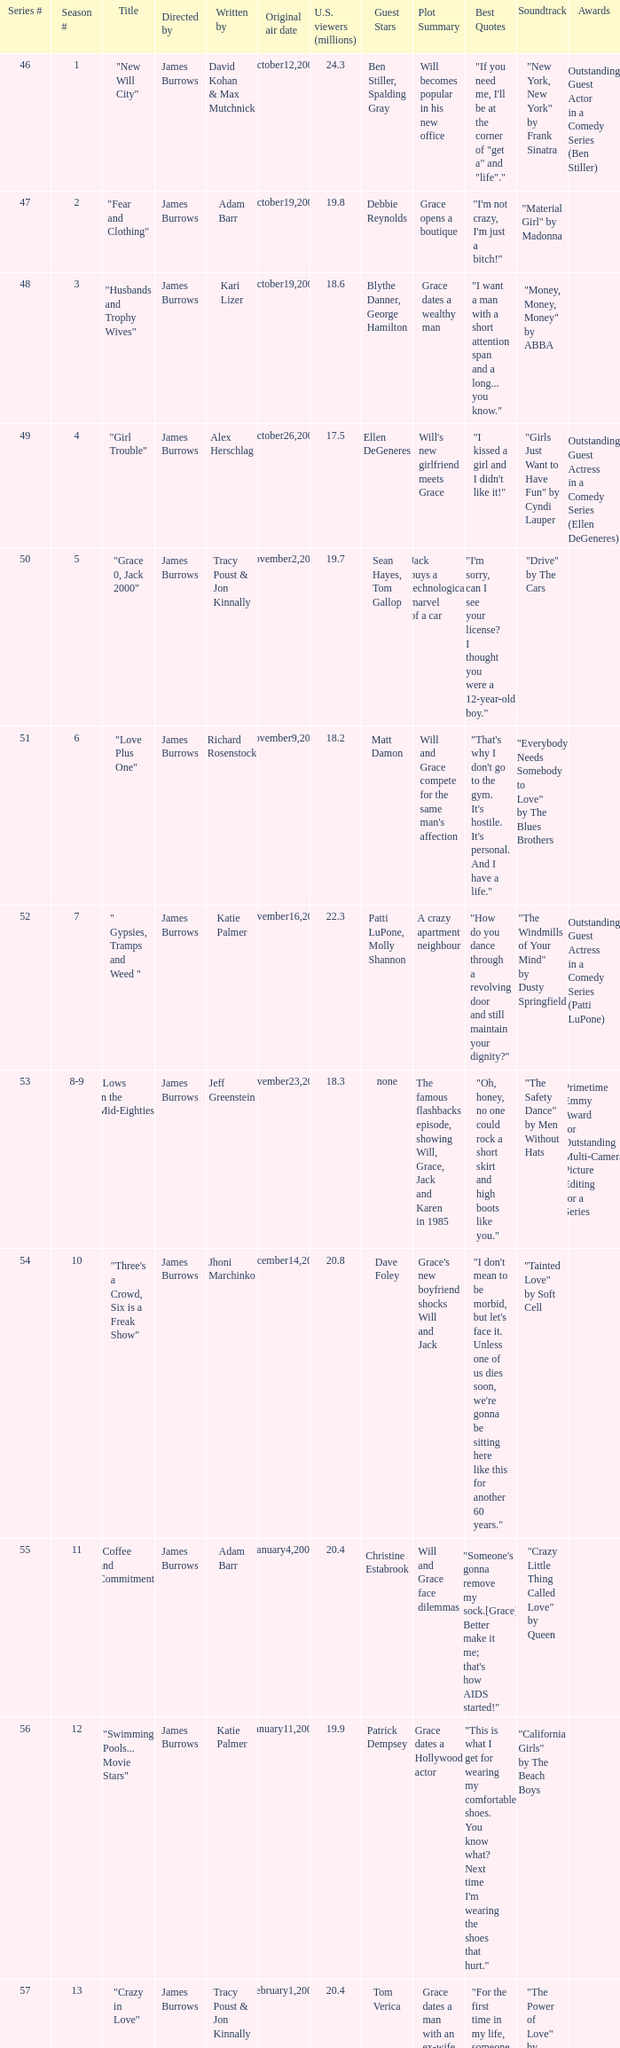Who wrote episode 23 in the season? Kari Lizer. 